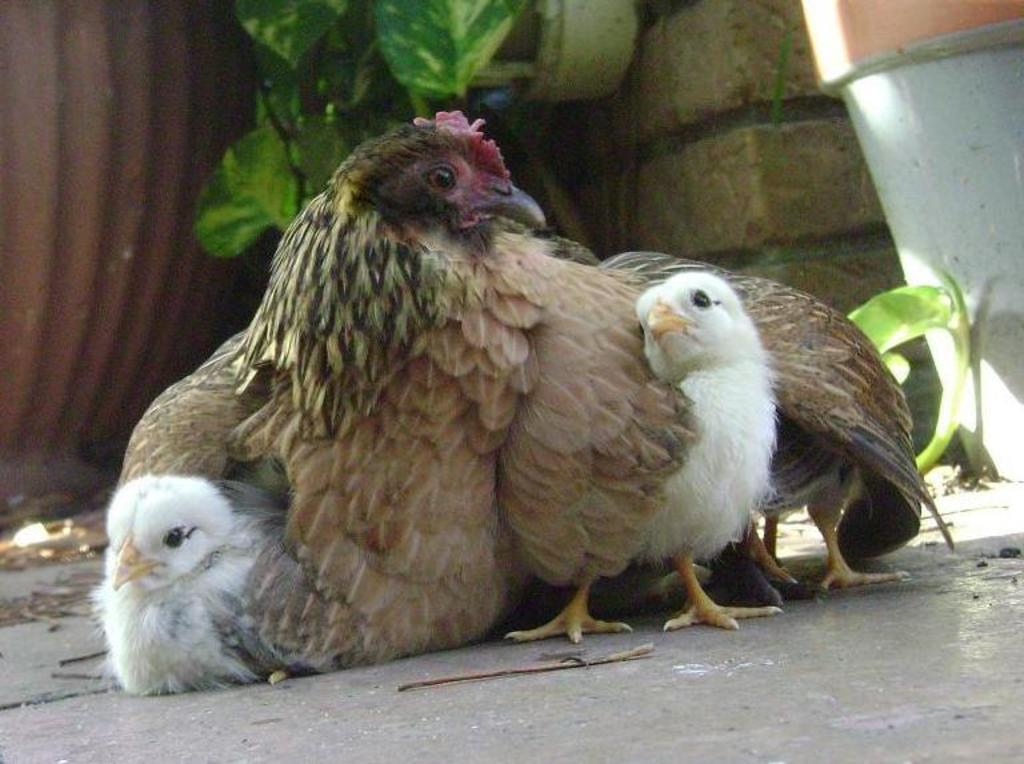What type of animals are in the image? There are hens in the image. What colors can be seen on the hens? The hens are in brown and white colors. What can be seen in the background of the image? There is a wall, a pot, a plant, and a few other objects in the background of the image. What type of process is being carried out in the oven in the image? There is no oven present in the image; it features hens and background elements. How does the tub affect the appearance of the hens in the image? There is no tub present in the image; it only features hens and background elements. 